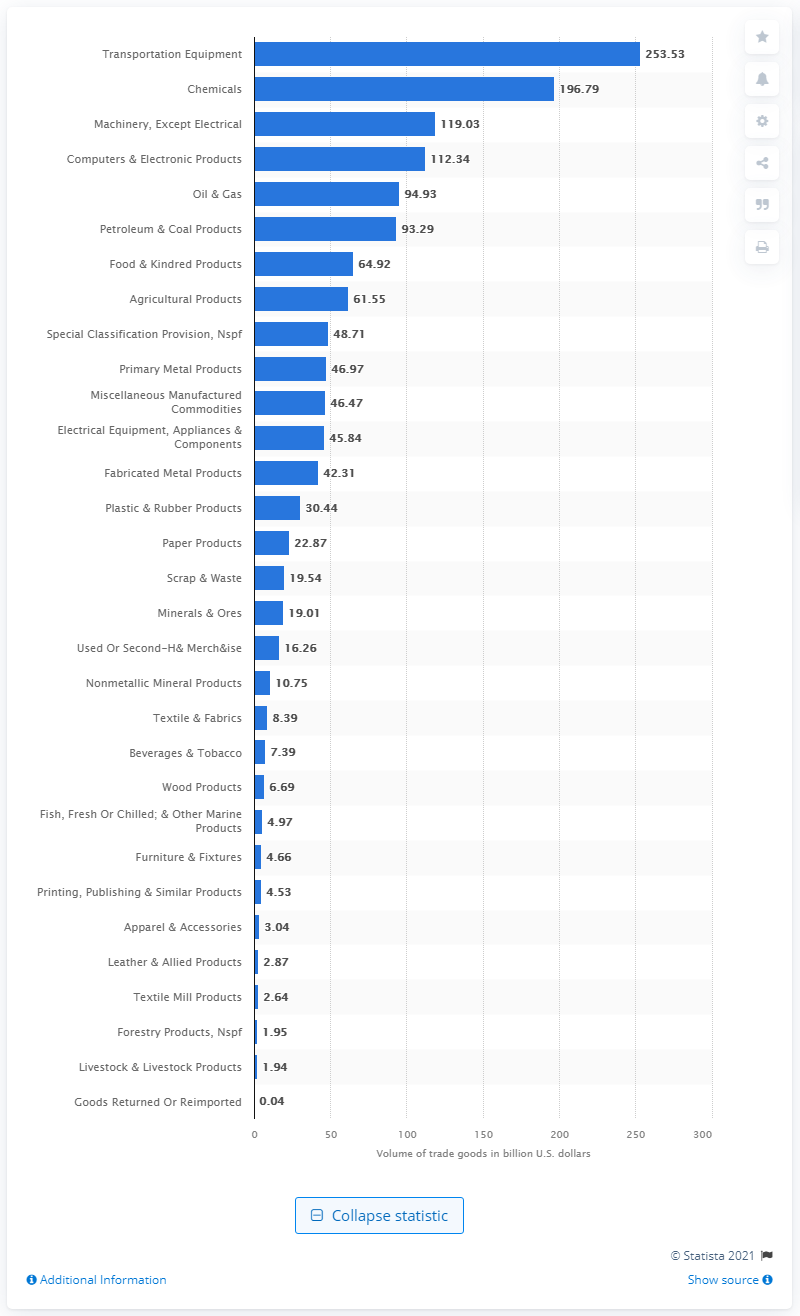Outline some significant characteristics in this image. In 2019, the United States exported $253.53 million worth of transportation equipment. 